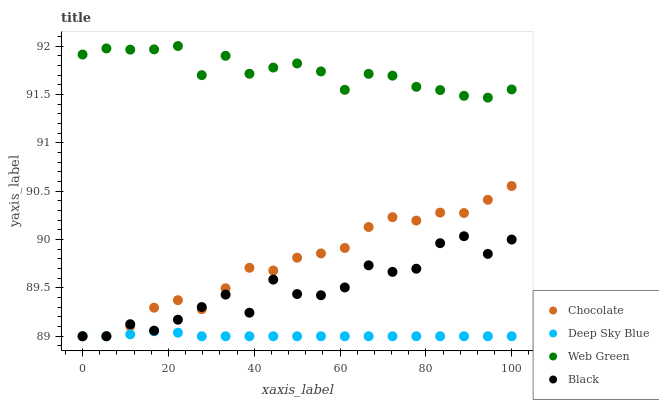Does Deep Sky Blue have the minimum area under the curve?
Answer yes or no. Yes. Does Web Green have the maximum area under the curve?
Answer yes or no. Yes. Does Web Green have the minimum area under the curve?
Answer yes or no. No. Does Deep Sky Blue have the maximum area under the curve?
Answer yes or no. No. Is Deep Sky Blue the smoothest?
Answer yes or no. Yes. Is Black the roughest?
Answer yes or no. Yes. Is Web Green the smoothest?
Answer yes or no. No. Is Web Green the roughest?
Answer yes or no. No. Does Black have the lowest value?
Answer yes or no. Yes. Does Web Green have the lowest value?
Answer yes or no. No. Does Web Green have the highest value?
Answer yes or no. Yes. Does Deep Sky Blue have the highest value?
Answer yes or no. No. Is Black less than Web Green?
Answer yes or no. Yes. Is Web Green greater than Black?
Answer yes or no. Yes. Does Chocolate intersect Black?
Answer yes or no. Yes. Is Chocolate less than Black?
Answer yes or no. No. Is Chocolate greater than Black?
Answer yes or no. No. Does Black intersect Web Green?
Answer yes or no. No. 